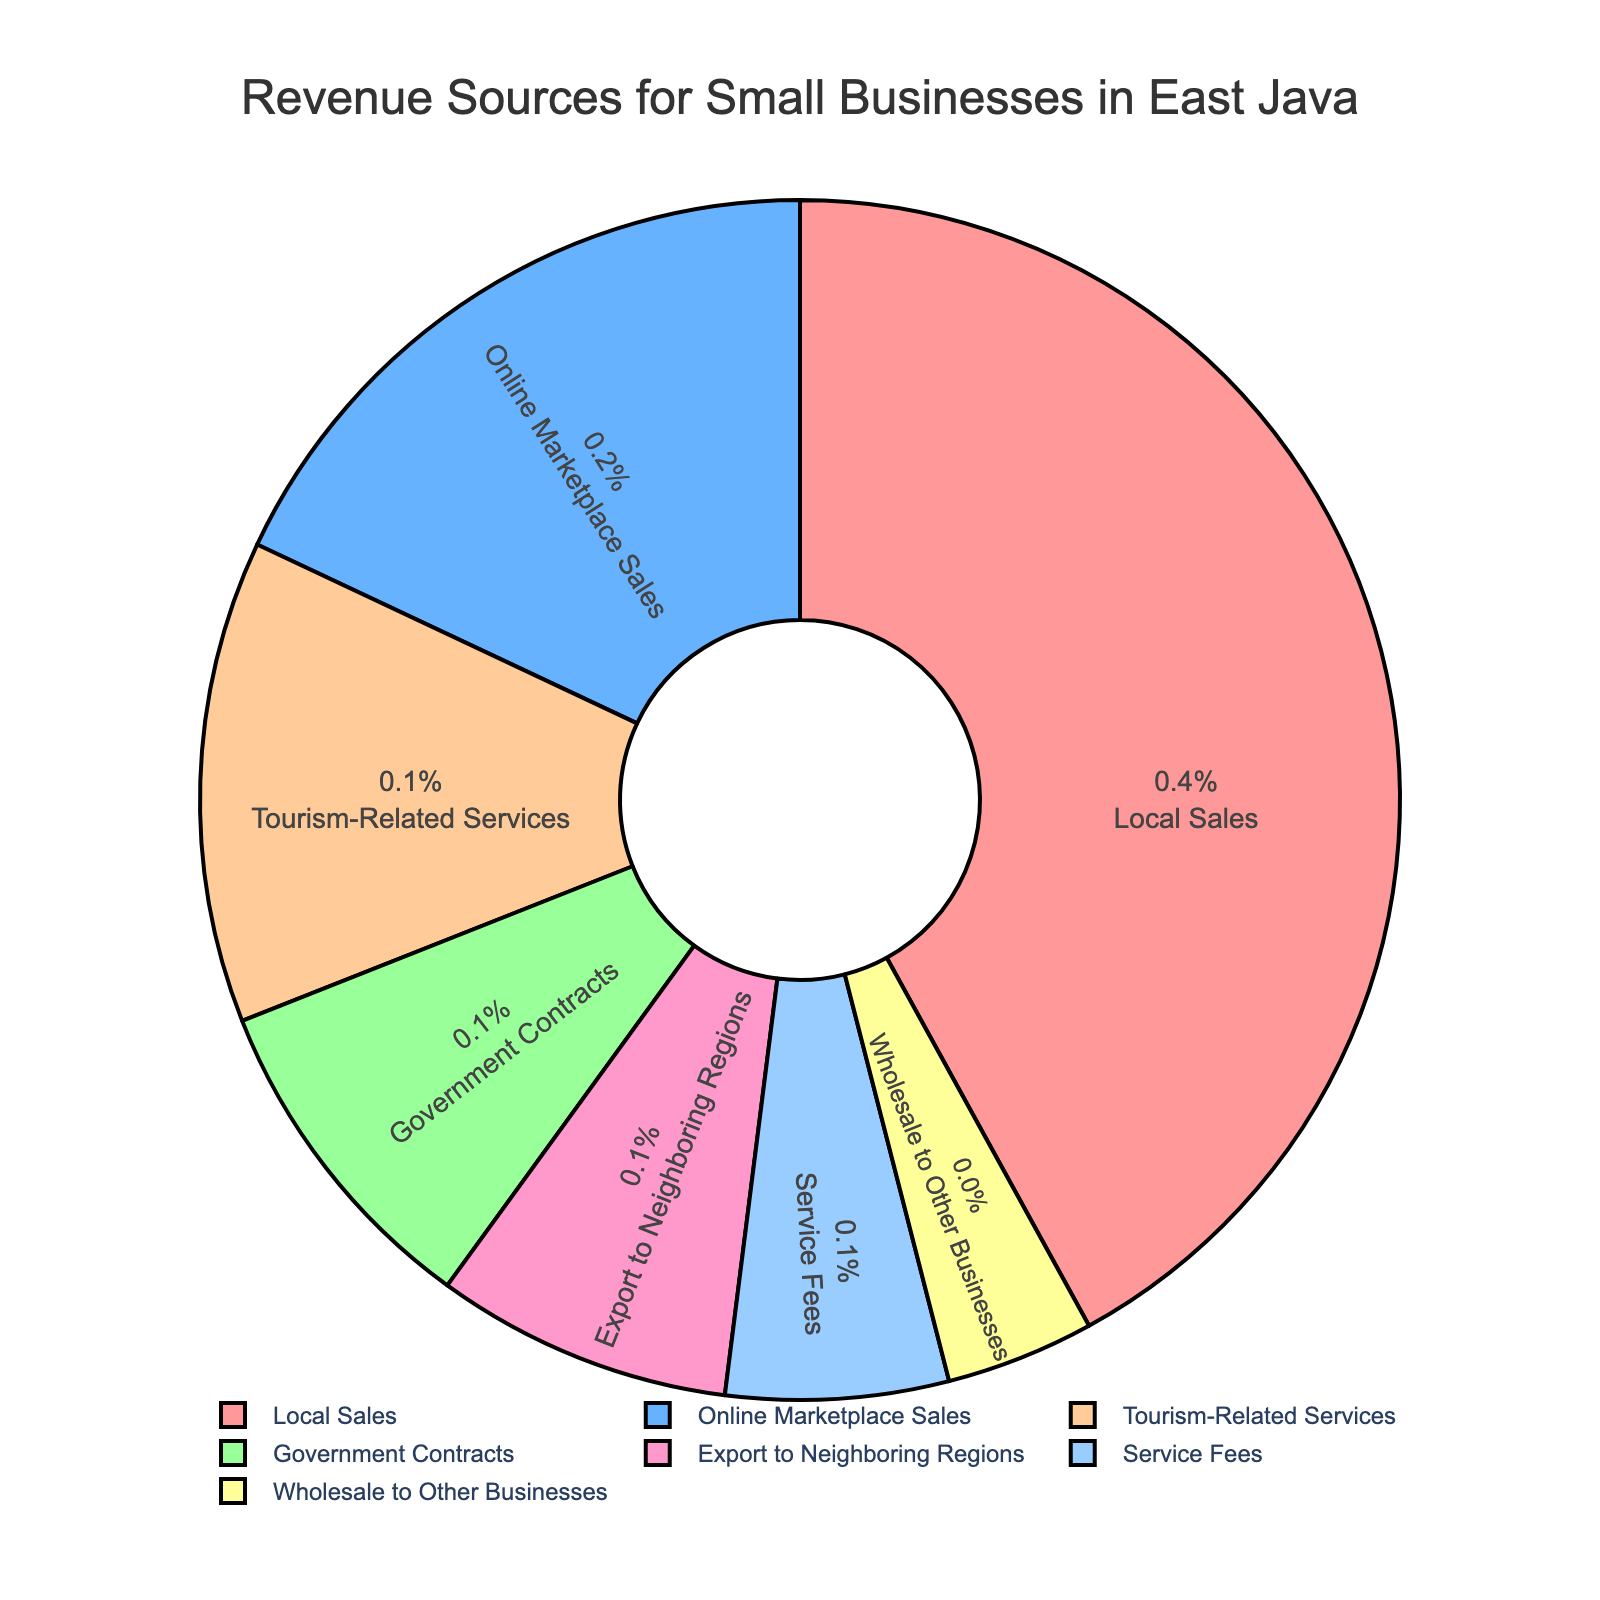What is the largest revenue source for small businesses in East Java? The largest segment on the pie chart represents Local Sales with the highest percentage.
Answer: Local Sales Which revenue source contributes the least percentage? The smallest segment on the pie chart represents Wholesale to Other Businesses.
Answer: Wholesale to Other Businesses How much higher is the percentage of Local Sales compared to Online Marketplace Sales? Local Sales contribute 42% while Online Marketplace Sales contribute 18%. The difference is 42% - 18% = 24%.
Answer: 24% What sources combined make up exactly half of the revenue? Local Sales is 42% and Online Marketplace Sales is 18%. Summing them up gives 42% + 18% = 60%. This exceeds half, so looking at Local Sales and Tourism-Related Services: 42% + 13% = 55%, still over half. Next, Local Sales and Government Contracts: 42% + 9% = 51%, which is just over half. So there isn't an exact 50% through visible combinations.
Answer: None What proportion of the revenue comes from tourism-related services compared to government contracts? Tourism-Related Services contribute 13%, and Government Contracts contribute 9%. The proportion is 13% / 9% = 1.44 (or 13:9 ratio).
Answer: 1.44 If you combine the percentages for Government Contracts and Service Fees, what percentage of the revenue do you get? Government Contracts contribute 9% and Service Fees contribute 6%. Combining these gives 9% + 6% = 15%.
Answer: 15% Which segment is larger: Tourism-Related Services or Exports to Neighboring Regions, and by how much? Tourism-Related Services contribute 13%, and Export to Neighboring Regions contributes 8%. The difference is 13% - 8% = 5%.
Answer: Tourism-Related Services by 5% How much more revenue do local sales generate than all service-related sources combined (Tourism-Related Services and Service Fees)? Local Sales contribute 42%. Tourism-Related Services contribute 13% and Service Fees contribute 6%. The combined total for service-related sources is 13% + 6% = 19%. The difference is 42% - 19% = 23%.
Answer: 23% What are the colors of the top three revenue sources? The colors for Local Sales, Online Marketplace Sales, and Tourism-Related Services are shown as red, blue, and green respectively in the chart.
Answer: Red, Blue, Green Which has a larger share: Export to Neighboring Regions or Wholesale to Other Businesses, and by how much? Export to Neighboring Regions contributes 8%, while Wholesale to Other Businesses contributes 4%. The difference is 8% - 4% = 4%.
Answer: Export to Neighboring Regions by 4% 